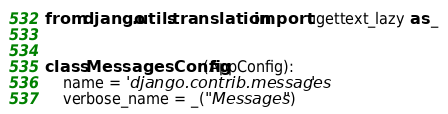Convert code to text. <code><loc_0><loc_0><loc_500><loc_500><_Python_>from django.utils.translation import ugettext_lazy as _


class MessagesConfig(AppConfig):
    name = 'django.contrib.messages'
    verbose_name = _("Messages")
</code> 